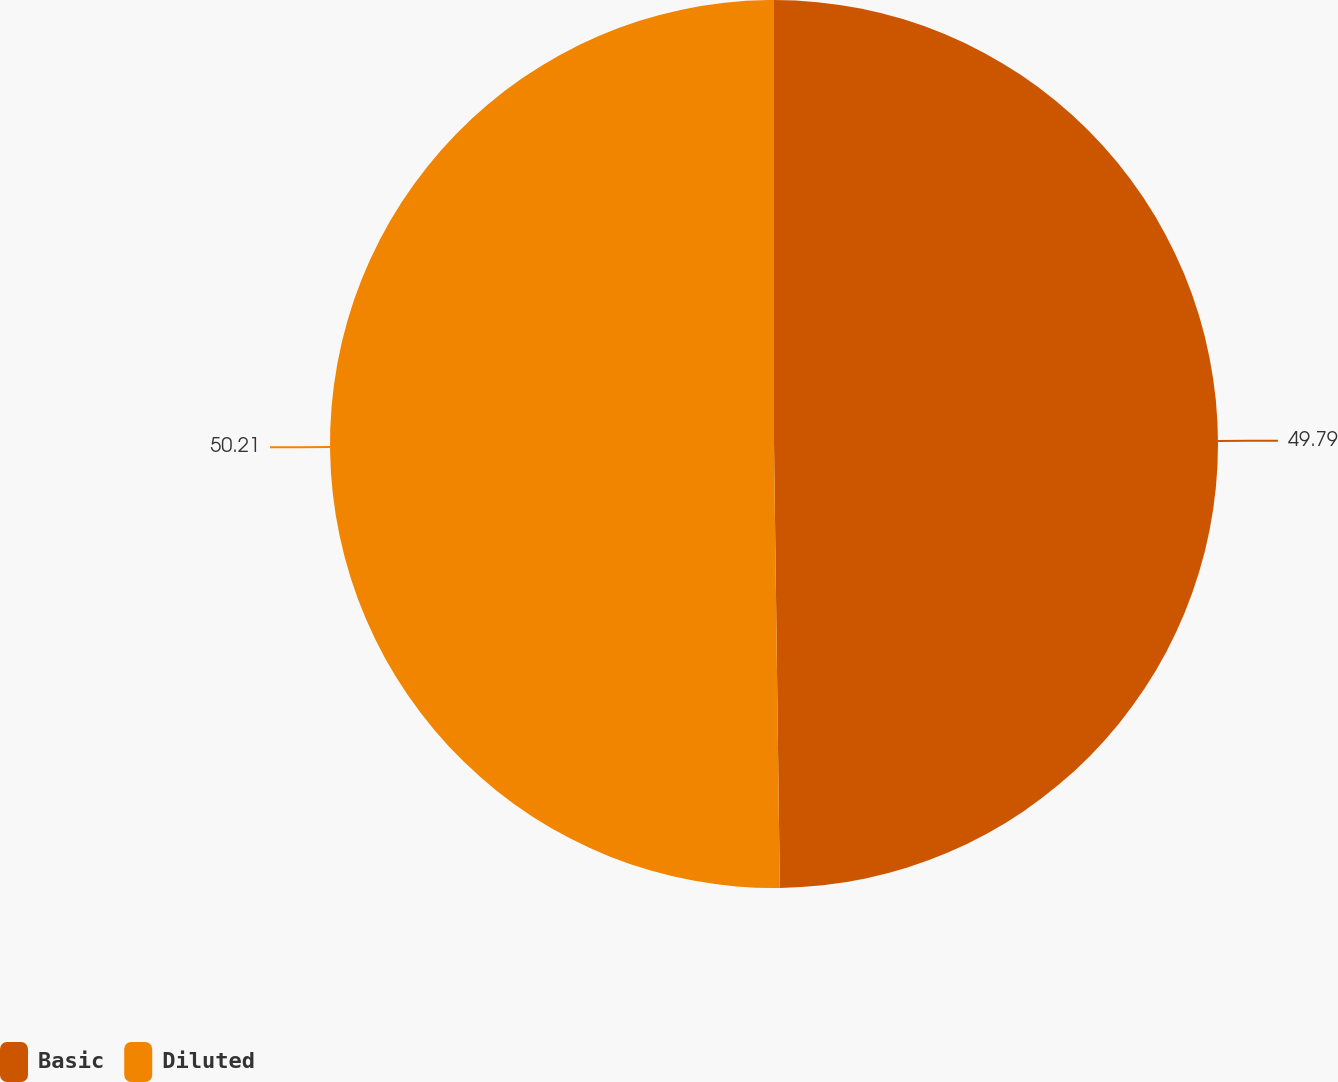Convert chart to OTSL. <chart><loc_0><loc_0><loc_500><loc_500><pie_chart><fcel>Basic<fcel>Diluted<nl><fcel>49.79%<fcel>50.21%<nl></chart> 